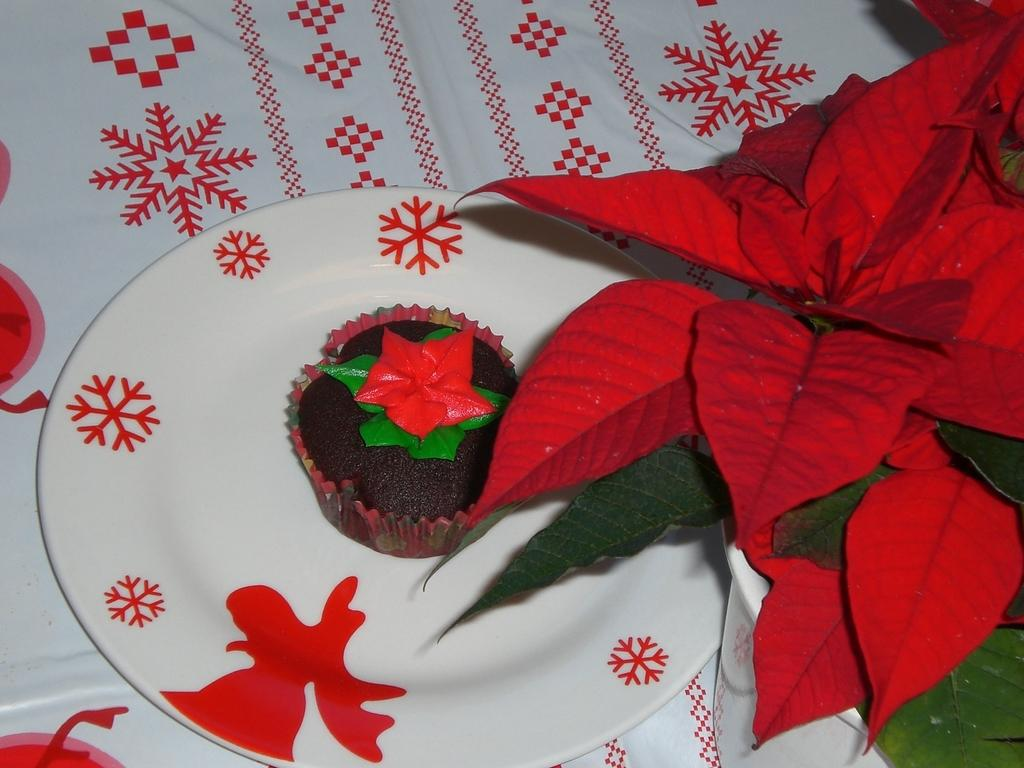What type of food is visible in the image? There is a muffin with cream in the image. How is the muffin presented in the image? The muffin is placed on a plate. What is the plate resting on in the image? The plate is placed on a cloth. What can be seen on the right side of the image? There are leaves and a pot on the right side of the image. How many cows are visible in the image? There are no cows present in the image. What thought is the muffin having in the image? Muffins do not have thoughts, as they are inanimate objects. How many steps are visible in the image? There is no mention of steps in the provided facts, so it cannot be determined from the image. 